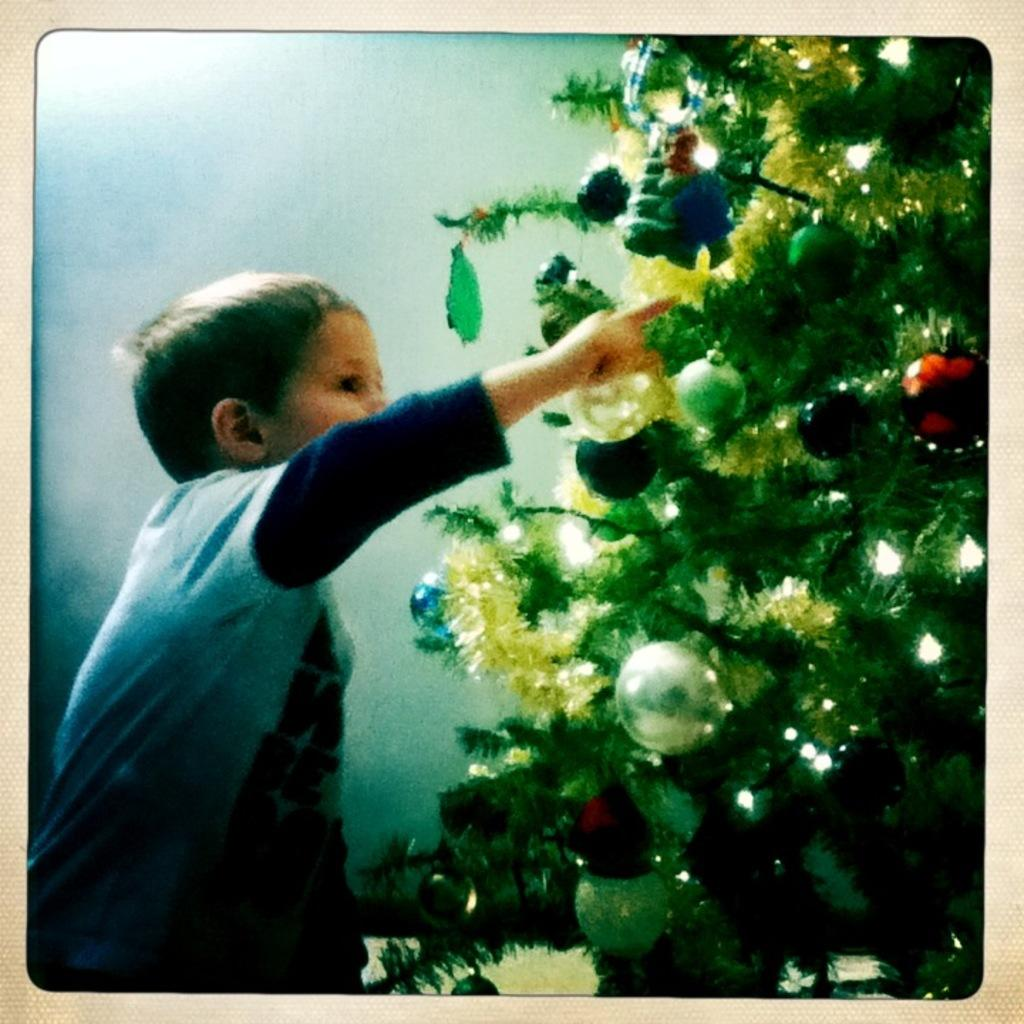Who is present in the image? There is a boy in the image. What is the boy doing in the image? The boy is standing at a Christmas tree. What type of store is the boy in, and where is the shelf with the toys located? There is no information about a store or shelf in the image. The image only shows a boy standing at a Christmas tree. 